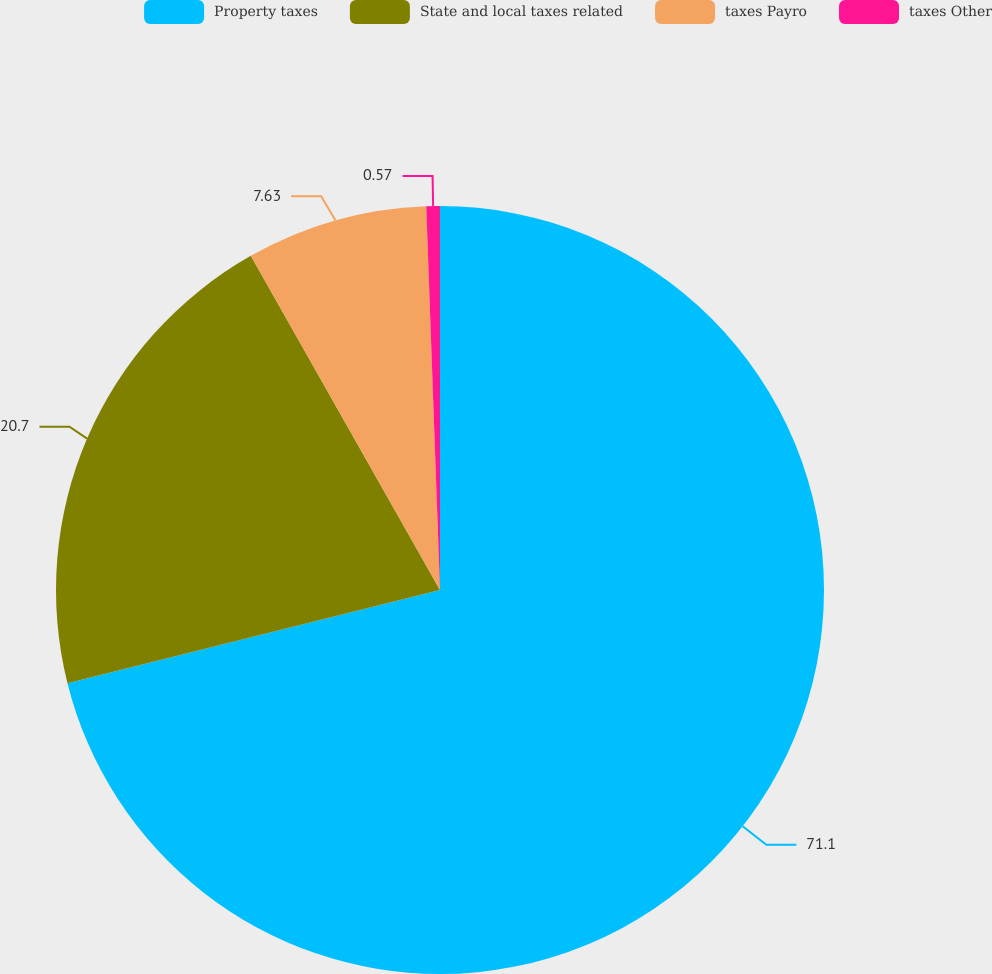Convert chart to OTSL. <chart><loc_0><loc_0><loc_500><loc_500><pie_chart><fcel>Property taxes<fcel>State and local taxes related<fcel>taxes Payro<fcel>taxes Other<nl><fcel>71.1%<fcel>20.7%<fcel>7.63%<fcel>0.57%<nl></chart> 